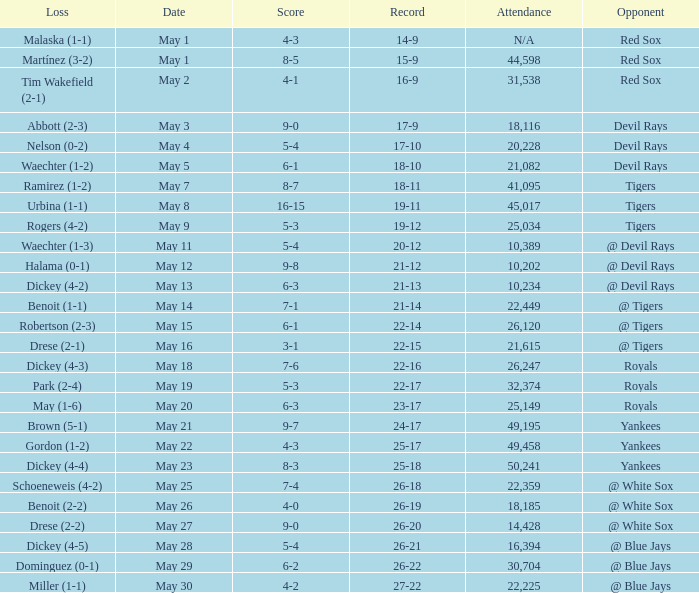What was the score of the game that had a loss of Drese (2-2)? 9-0. 